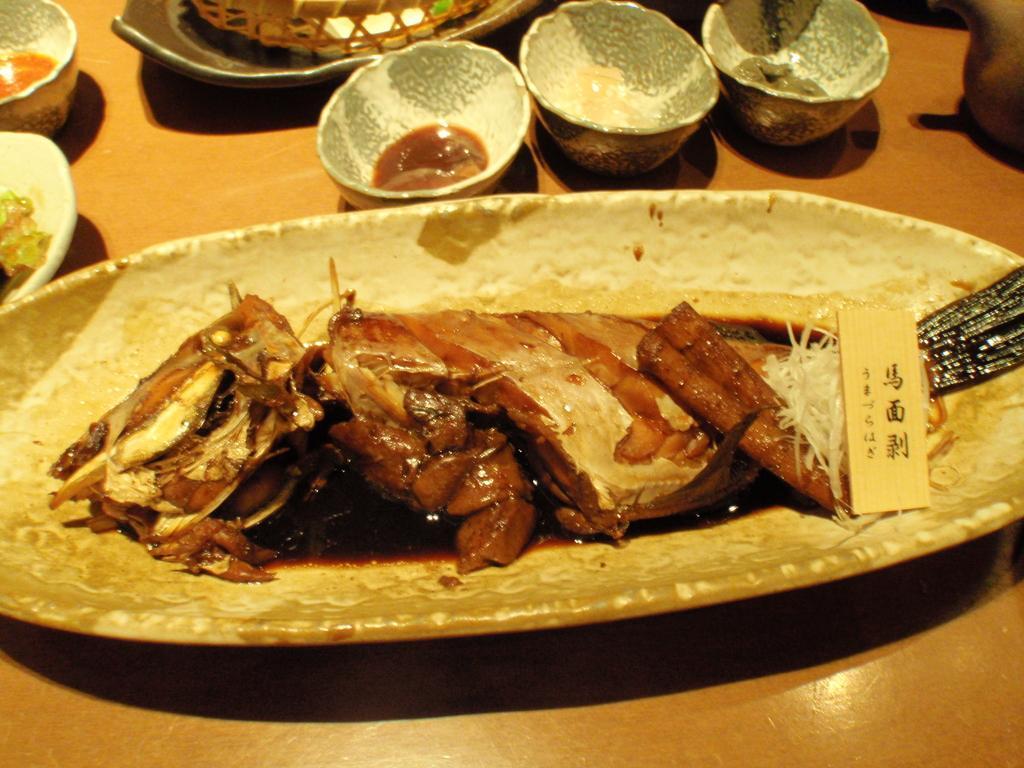Could you give a brief overview of what you see in this image? In this picture we can see plate, food, bowls and objects on the wooden platform. 